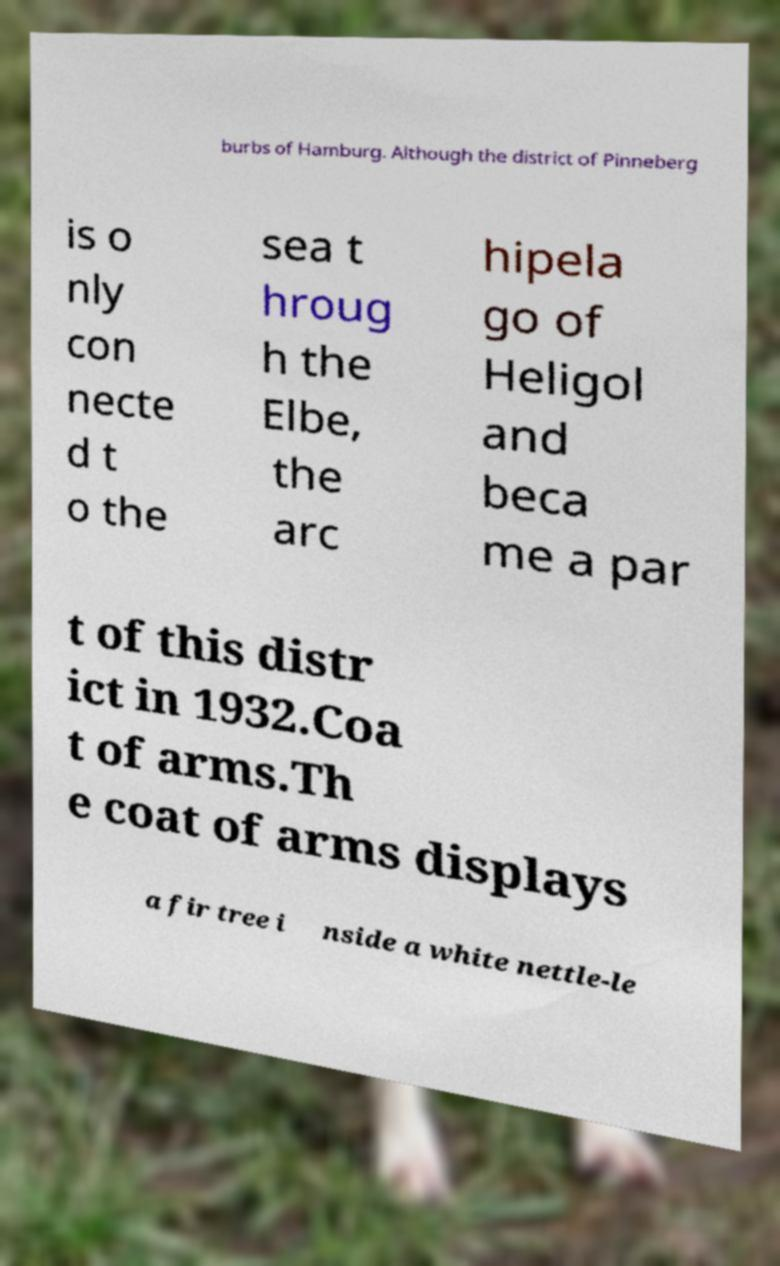Could you assist in decoding the text presented in this image and type it out clearly? burbs of Hamburg. Although the district of Pinneberg is o nly con necte d t o the sea t hroug h the Elbe, the arc hipela go of Heligol and beca me a par t of this distr ict in 1932.Coa t of arms.Th e coat of arms displays a fir tree i nside a white nettle-le 